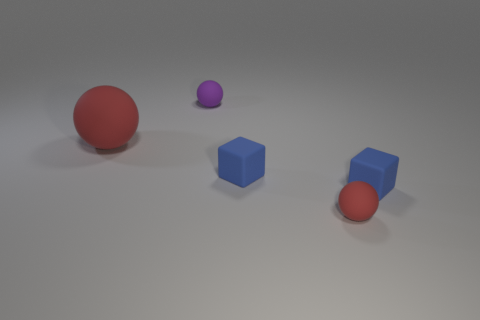Are there fewer blue objects that are behind the purple rubber ball than tiny blue cylinders? After examining the image, it appears that there is only one blue cube situated behind the purple rubber ball, and there are two tiny blue cylinders in front. Therefore, the answer is yes; there are fewer blue objects behind the purple rubber ball than tiny blue cylinders. 